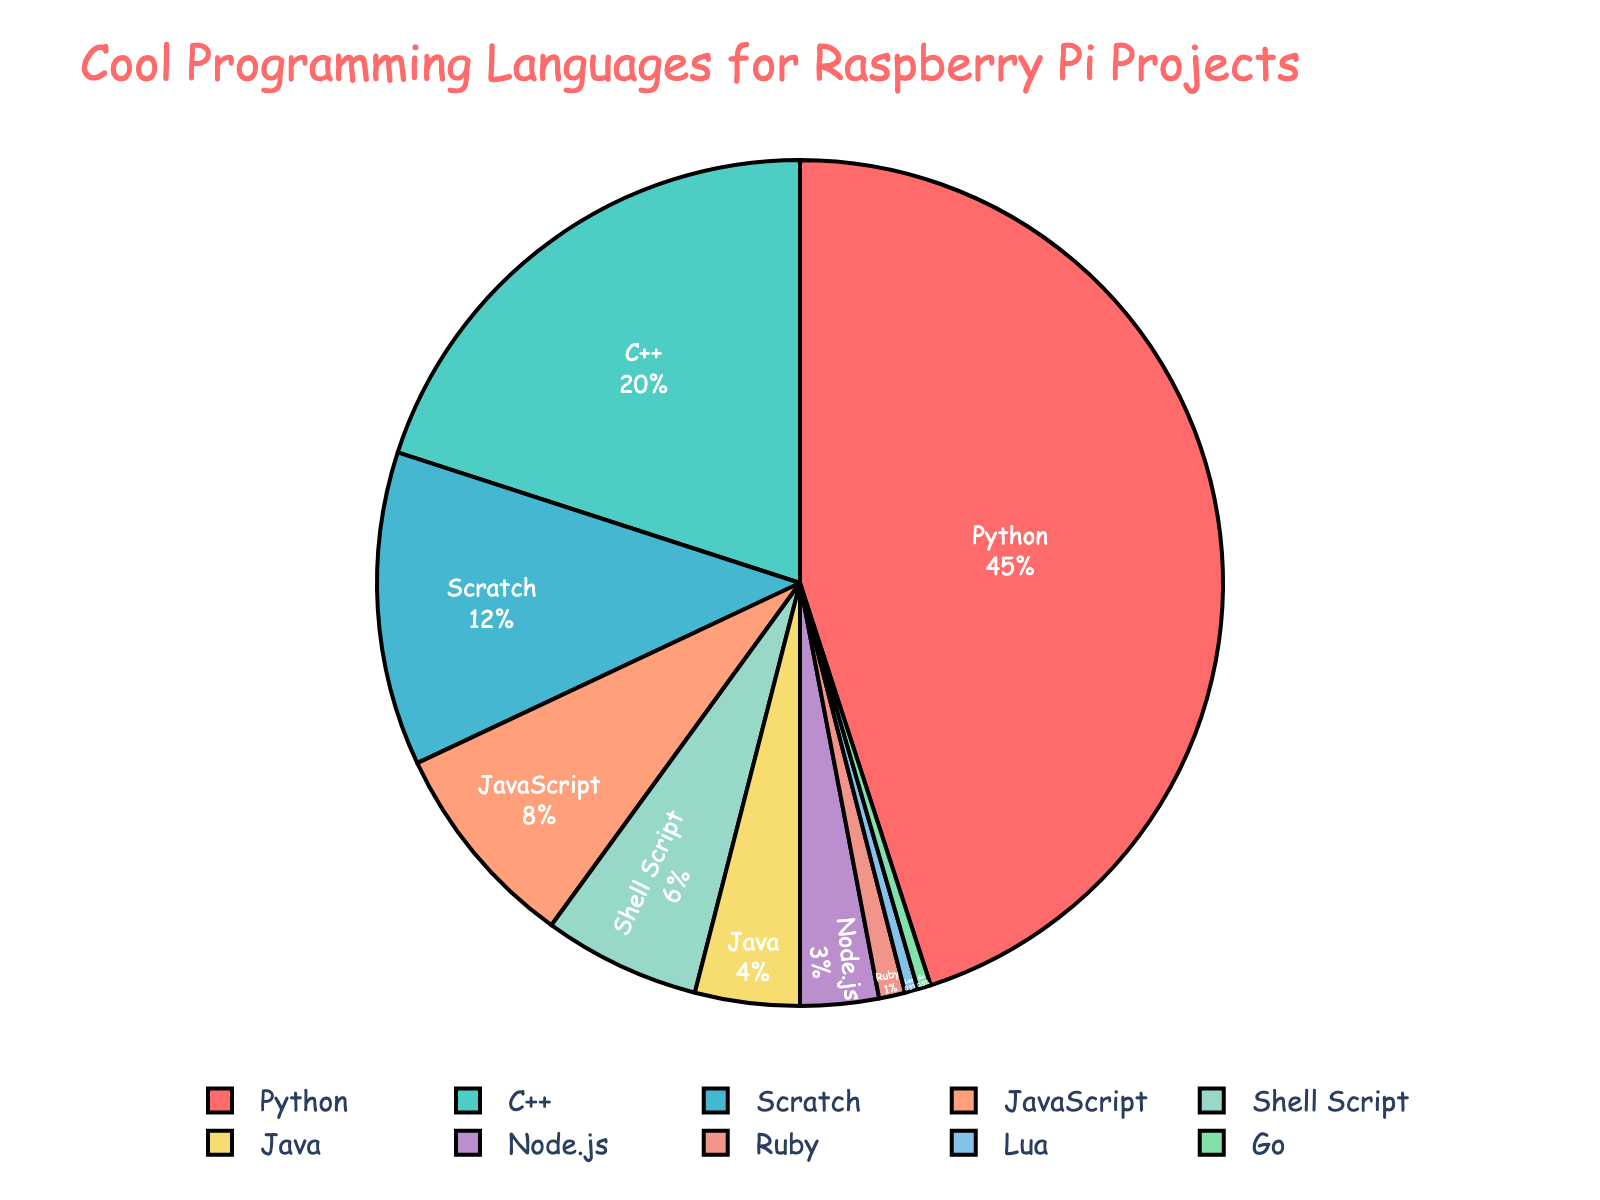What percentage of Raspberry Pi projects use Python? Locate the segment labeled "Python" on the pie chart. The label indicates that Python is used in 45% of Raspberry Pi projects.
Answer: 45% Which language ranks second in terms of usage? Identify the largest segments first. Python is the largest, followed by the segment for C++ which is marked as 20%.
Answer: C++ How much more popular is Python compared to JavaScript? Find the segments for Python and JavaScript, which show 45% and 8% respectively. Subtract the JavaScript percentage from the Python percentage: 45% - 8% = 37%.
Answer: 37% Which languages have a usage percentage of less than 5%? Look for segments with percentages less than 5%. The segments for Java (4%), Node.js (3%), Ruby (1%), Lua (0.5%), and Go (0.5%) all meet this criterion.
Answer: Java, Node.js, Ruby, Lua, Go How do the combined usage percentages of Scratch and Shell Script compare to Python’s usage percentage? Find the percentages for Scratch (12%) and Shell Script (6%). Add them together to get 18%. Then compare this to Python's 45%.
Answer: 18% vs 45% What is the total percentage of projects using languages other than Python, C++, and Scratch? Find and sum the percentages for languages other than Python (45%), C++ (20%), and Scratch (12%). The remaining languages are JavaScript (8%), Shell Script (6%), Java (4%), Node.js (3%), Ruby (1%), Lua (0.5%), and Go (0.5%). Adding these gives 23%.
Answer: 23% Which slice is colored red and what percentage does it represent? Locate the red segment on the pie chart. This segment represents Python, with a percentage of 45%.
Answer: Python, 45% How does the sum of usage percentages for JavaScript and Shell Script compare to the sum of percentages for Java and Node.js? Find the values for JavaScript (8%) and Shell Script (6%), which sum to 14%. Then find the values for Java (4%) and Node.js (3%), which sum to 7%. Compare these sums: 14% is greater than 7%.
Answer: 14% vs 7% What is the smallest segment on the chart and what language does it represent? Identify the smallest segment by examining the pie chart. The segment for Go and Lua each represents 0.5%, which is the smallest percentage.
Answer: Go, Lua 